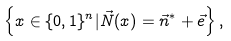<formula> <loc_0><loc_0><loc_500><loc_500>\left \{ x \in \{ 0 , 1 \} ^ { n } | \vec { N } ( x ) = \vec { n } ^ { * } + \vec { e } \right \} ,</formula> 